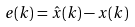Convert formula to latex. <formula><loc_0><loc_0><loc_500><loc_500>e ( k ) = \hat { x } ( k ) - x ( k )</formula> 